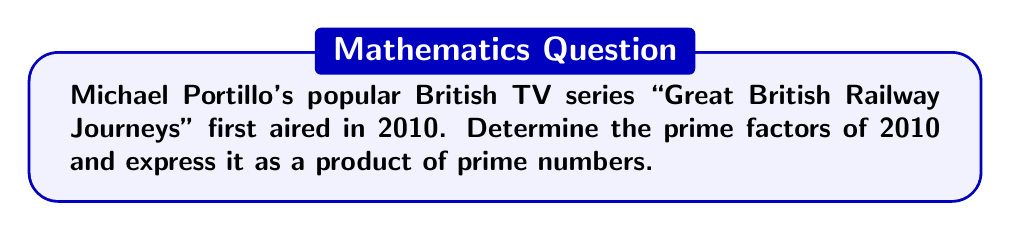What is the answer to this math problem? To find the prime factors of 2010, we'll use the following steps:

1) First, let's check if 2010 is divisible by the smallest prime number, 2:
   $2010 \div 2 = 1005$ (no remainder)
   So, 2 is a prime factor.

2) Now, we continue dividing 1005 by prime numbers:
   $1005 \div 3 = 335$ (no remainder)
   So, 3 is a prime factor.

3) We continue with 335:
   $335 \div 5 = 67$ (no remainder)
   So, 5 is a prime factor.

4) 67 is itself a prime number, so we stop here.

Therefore, we can express 2010 as:

$$2010 = 2 \times 3 \times 5 \times 67$$

This is the prime factorization of 2010.
Answer: The prime factorization of 2010 is: $2010 = 2 \times 3 \times 5 \times 67$ 